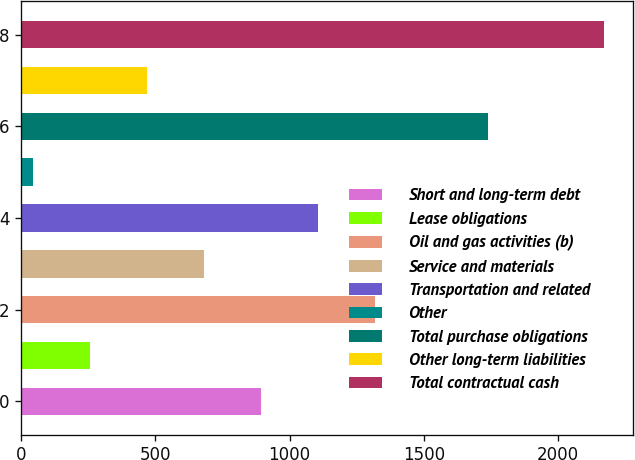<chart> <loc_0><loc_0><loc_500><loc_500><bar_chart><fcel>Short and long-term debt<fcel>Lease obligations<fcel>Oil and gas activities (b)<fcel>Service and materials<fcel>Transportation and related<fcel>Other<fcel>Total purchase obligations<fcel>Other long-term liabilities<fcel>Total contractual cash<nl><fcel>893.6<fcel>254.9<fcel>1319.4<fcel>680.7<fcel>1106.5<fcel>42<fcel>1741<fcel>467.8<fcel>2171<nl></chart> 